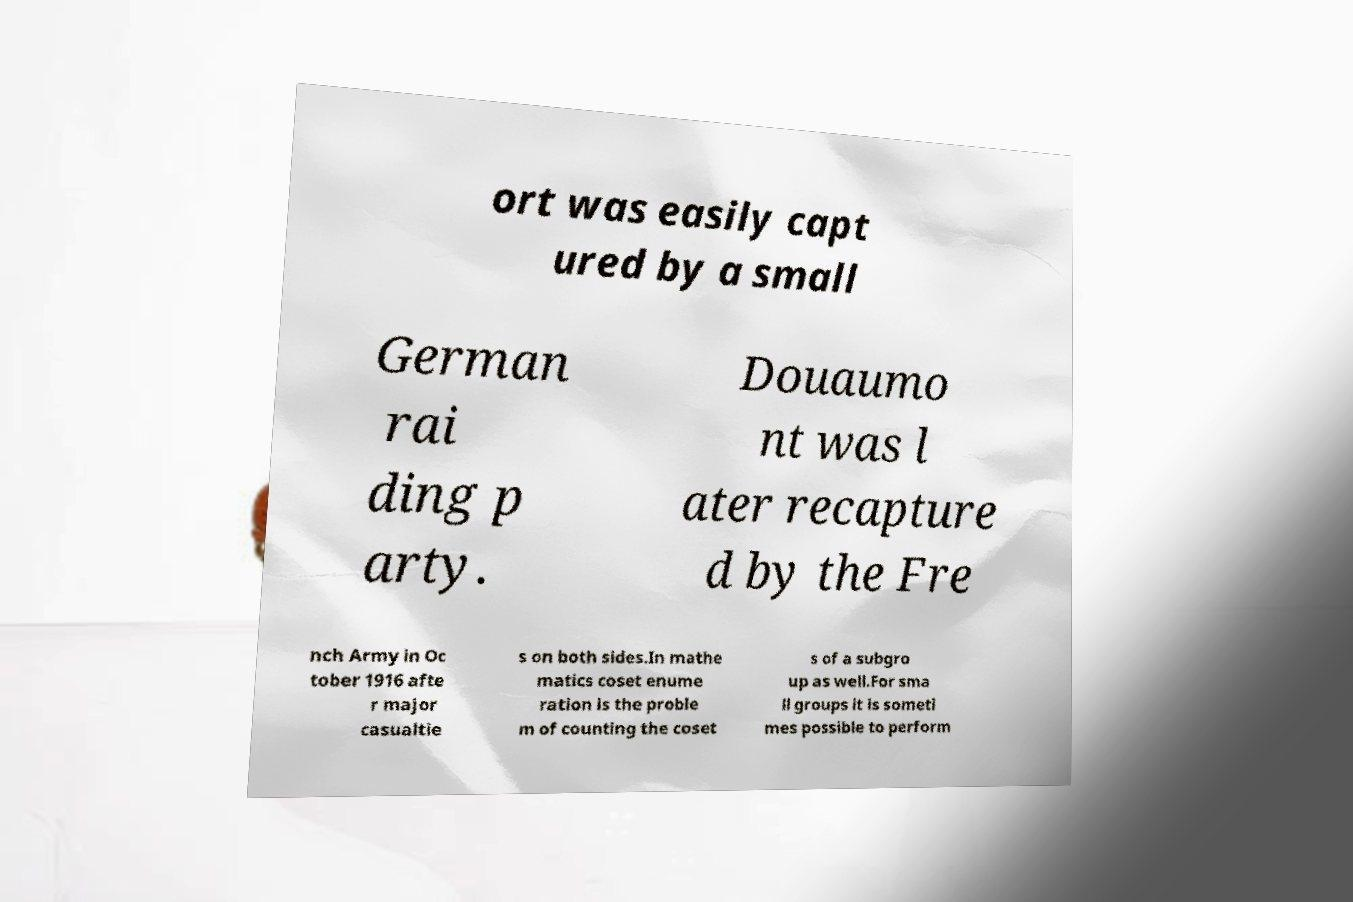There's text embedded in this image that I need extracted. Can you transcribe it verbatim? ort was easily capt ured by a small German rai ding p arty. Douaumo nt was l ater recapture d by the Fre nch Army in Oc tober 1916 afte r major casualtie s on both sides.In mathe matics coset enume ration is the proble m of counting the coset s of a subgro up as well.For sma ll groups it is someti mes possible to perform 